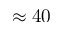<formula> <loc_0><loc_0><loc_500><loc_500>\approx 4 0</formula> 